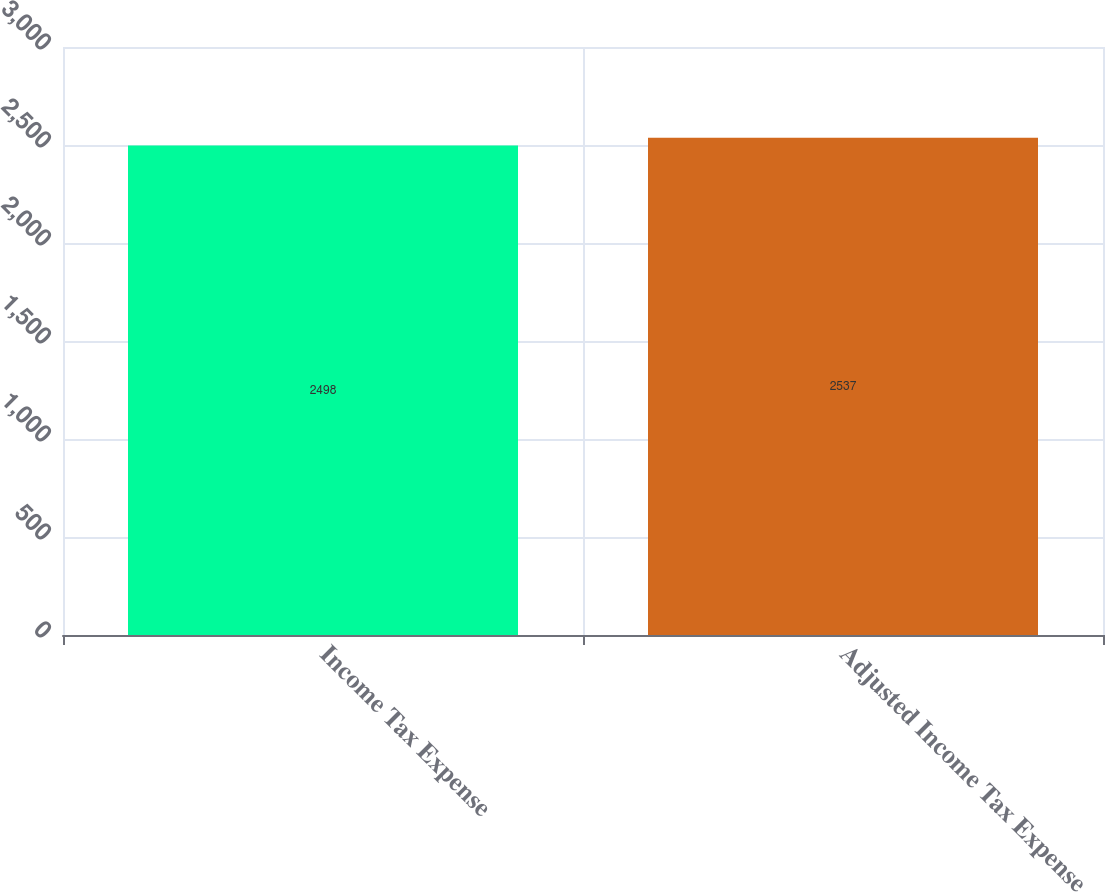<chart> <loc_0><loc_0><loc_500><loc_500><bar_chart><fcel>Income Tax Expense<fcel>Adjusted Income Tax Expense<nl><fcel>2498<fcel>2537<nl></chart> 